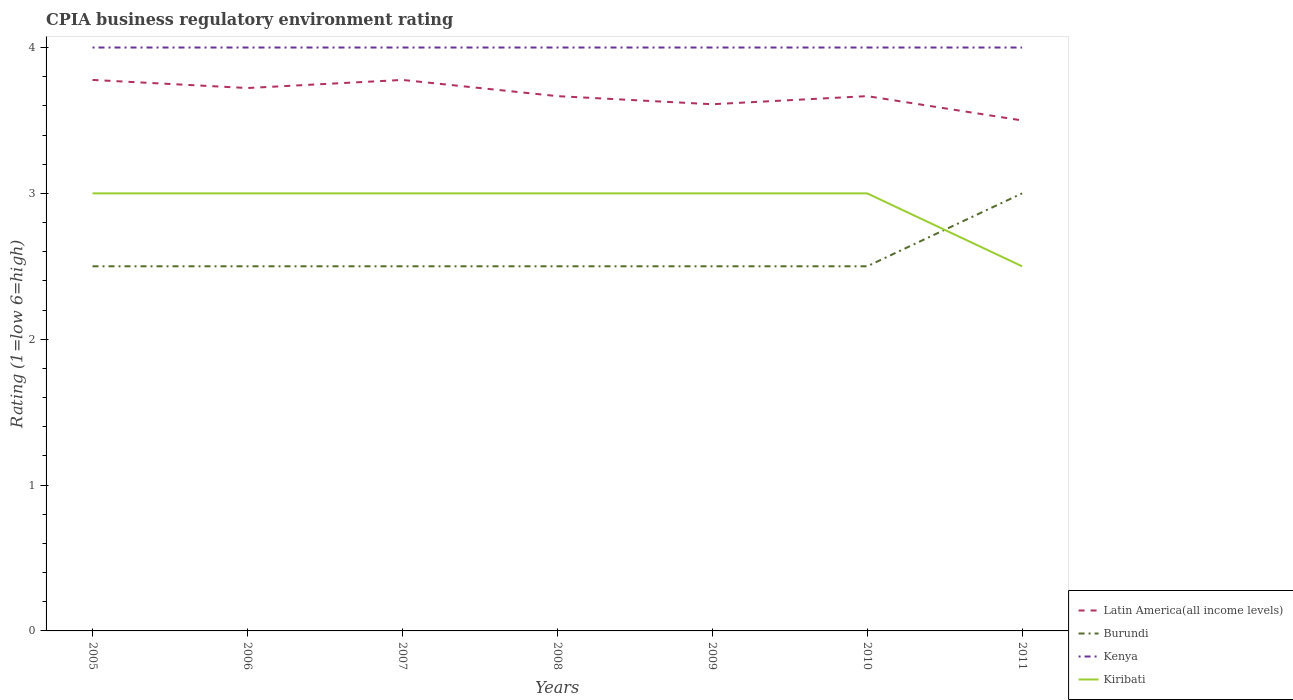How many different coloured lines are there?
Make the answer very short. 4. Across all years, what is the maximum CPIA rating in Burundi?
Your response must be concise. 2.5. In which year was the CPIA rating in Kiribati maximum?
Offer a very short reply. 2011. What is the total CPIA rating in Latin America(all income levels) in the graph?
Provide a succinct answer. 0.11. What is the difference between the highest and the second highest CPIA rating in Kenya?
Your answer should be very brief. 0. What is the difference between the highest and the lowest CPIA rating in Kenya?
Offer a very short reply. 0. How many lines are there?
Your answer should be compact. 4. How many years are there in the graph?
Your response must be concise. 7. What is the difference between two consecutive major ticks on the Y-axis?
Provide a short and direct response. 1. Does the graph contain grids?
Offer a terse response. No. Where does the legend appear in the graph?
Provide a succinct answer. Bottom right. How are the legend labels stacked?
Keep it short and to the point. Vertical. What is the title of the graph?
Give a very brief answer. CPIA business regulatory environment rating. What is the label or title of the Y-axis?
Your answer should be compact. Rating (1=low 6=high). What is the Rating (1=low 6=high) of Latin America(all income levels) in 2005?
Give a very brief answer. 3.78. What is the Rating (1=low 6=high) of Burundi in 2005?
Your response must be concise. 2.5. What is the Rating (1=low 6=high) of Latin America(all income levels) in 2006?
Make the answer very short. 3.72. What is the Rating (1=low 6=high) in Kiribati in 2006?
Provide a short and direct response. 3. What is the Rating (1=low 6=high) in Latin America(all income levels) in 2007?
Make the answer very short. 3.78. What is the Rating (1=low 6=high) of Burundi in 2007?
Ensure brevity in your answer.  2.5. What is the Rating (1=low 6=high) in Kiribati in 2007?
Make the answer very short. 3. What is the Rating (1=low 6=high) of Latin America(all income levels) in 2008?
Offer a very short reply. 3.67. What is the Rating (1=low 6=high) in Kenya in 2008?
Keep it short and to the point. 4. What is the Rating (1=low 6=high) of Kiribati in 2008?
Your response must be concise. 3. What is the Rating (1=low 6=high) of Latin America(all income levels) in 2009?
Offer a terse response. 3.61. What is the Rating (1=low 6=high) of Burundi in 2009?
Provide a succinct answer. 2.5. What is the Rating (1=low 6=high) in Kiribati in 2009?
Provide a succinct answer. 3. What is the Rating (1=low 6=high) of Latin America(all income levels) in 2010?
Give a very brief answer. 3.67. What is the Rating (1=low 6=high) of Kiribati in 2010?
Make the answer very short. 3. What is the Rating (1=low 6=high) in Latin America(all income levels) in 2011?
Give a very brief answer. 3.5. What is the Rating (1=low 6=high) in Burundi in 2011?
Keep it short and to the point. 3. What is the Rating (1=low 6=high) of Kiribati in 2011?
Offer a terse response. 2.5. Across all years, what is the maximum Rating (1=low 6=high) in Latin America(all income levels)?
Offer a terse response. 3.78. Across all years, what is the maximum Rating (1=low 6=high) of Burundi?
Your answer should be very brief. 3. Across all years, what is the maximum Rating (1=low 6=high) of Kenya?
Provide a short and direct response. 4. Across all years, what is the maximum Rating (1=low 6=high) in Kiribati?
Your response must be concise. 3. Across all years, what is the minimum Rating (1=low 6=high) in Kenya?
Ensure brevity in your answer.  4. What is the total Rating (1=low 6=high) in Latin America(all income levels) in the graph?
Provide a succinct answer. 25.72. What is the total Rating (1=low 6=high) in Kiribati in the graph?
Offer a terse response. 20.5. What is the difference between the Rating (1=low 6=high) in Latin America(all income levels) in 2005 and that in 2006?
Offer a terse response. 0.06. What is the difference between the Rating (1=low 6=high) of Kenya in 2005 and that in 2006?
Give a very brief answer. 0. What is the difference between the Rating (1=low 6=high) of Kiribati in 2005 and that in 2006?
Provide a succinct answer. 0. What is the difference between the Rating (1=low 6=high) in Latin America(all income levels) in 2005 and that in 2007?
Give a very brief answer. 0. What is the difference between the Rating (1=low 6=high) in Burundi in 2005 and that in 2007?
Provide a succinct answer. 0. What is the difference between the Rating (1=low 6=high) of Kiribati in 2005 and that in 2007?
Your response must be concise. 0. What is the difference between the Rating (1=low 6=high) in Burundi in 2005 and that in 2008?
Your response must be concise. 0. What is the difference between the Rating (1=low 6=high) of Kiribati in 2005 and that in 2009?
Your answer should be very brief. 0. What is the difference between the Rating (1=low 6=high) in Latin America(all income levels) in 2005 and that in 2010?
Give a very brief answer. 0.11. What is the difference between the Rating (1=low 6=high) in Burundi in 2005 and that in 2010?
Provide a succinct answer. 0. What is the difference between the Rating (1=low 6=high) in Kiribati in 2005 and that in 2010?
Keep it short and to the point. 0. What is the difference between the Rating (1=low 6=high) of Latin America(all income levels) in 2005 and that in 2011?
Offer a very short reply. 0.28. What is the difference between the Rating (1=low 6=high) of Latin America(all income levels) in 2006 and that in 2007?
Ensure brevity in your answer.  -0.06. What is the difference between the Rating (1=low 6=high) of Kenya in 2006 and that in 2007?
Your answer should be very brief. 0. What is the difference between the Rating (1=low 6=high) in Kiribati in 2006 and that in 2007?
Your response must be concise. 0. What is the difference between the Rating (1=low 6=high) in Latin America(all income levels) in 2006 and that in 2008?
Keep it short and to the point. 0.06. What is the difference between the Rating (1=low 6=high) in Burundi in 2006 and that in 2008?
Provide a succinct answer. 0. What is the difference between the Rating (1=low 6=high) of Kenya in 2006 and that in 2008?
Offer a terse response. 0. What is the difference between the Rating (1=low 6=high) in Burundi in 2006 and that in 2009?
Give a very brief answer. 0. What is the difference between the Rating (1=low 6=high) of Kenya in 2006 and that in 2009?
Ensure brevity in your answer.  0. What is the difference between the Rating (1=low 6=high) in Latin America(all income levels) in 2006 and that in 2010?
Your response must be concise. 0.06. What is the difference between the Rating (1=low 6=high) in Burundi in 2006 and that in 2010?
Offer a very short reply. 0. What is the difference between the Rating (1=low 6=high) of Kenya in 2006 and that in 2010?
Your answer should be compact. 0. What is the difference between the Rating (1=low 6=high) in Latin America(all income levels) in 2006 and that in 2011?
Make the answer very short. 0.22. What is the difference between the Rating (1=low 6=high) of Burundi in 2006 and that in 2011?
Make the answer very short. -0.5. What is the difference between the Rating (1=low 6=high) in Latin America(all income levels) in 2007 and that in 2008?
Give a very brief answer. 0.11. What is the difference between the Rating (1=low 6=high) of Kenya in 2007 and that in 2008?
Ensure brevity in your answer.  0. What is the difference between the Rating (1=low 6=high) in Burundi in 2007 and that in 2009?
Your answer should be very brief. 0. What is the difference between the Rating (1=low 6=high) in Burundi in 2007 and that in 2010?
Provide a short and direct response. 0. What is the difference between the Rating (1=low 6=high) of Kiribati in 2007 and that in 2010?
Your response must be concise. 0. What is the difference between the Rating (1=low 6=high) of Latin America(all income levels) in 2007 and that in 2011?
Provide a short and direct response. 0.28. What is the difference between the Rating (1=low 6=high) in Burundi in 2007 and that in 2011?
Keep it short and to the point. -0.5. What is the difference between the Rating (1=low 6=high) of Kenya in 2007 and that in 2011?
Provide a succinct answer. 0. What is the difference between the Rating (1=low 6=high) in Kiribati in 2007 and that in 2011?
Provide a succinct answer. 0.5. What is the difference between the Rating (1=low 6=high) in Latin America(all income levels) in 2008 and that in 2009?
Your answer should be very brief. 0.06. What is the difference between the Rating (1=low 6=high) in Kenya in 2008 and that in 2009?
Your answer should be very brief. 0. What is the difference between the Rating (1=low 6=high) in Burundi in 2008 and that in 2010?
Give a very brief answer. 0. What is the difference between the Rating (1=low 6=high) of Kenya in 2008 and that in 2011?
Your answer should be compact. 0. What is the difference between the Rating (1=low 6=high) of Latin America(all income levels) in 2009 and that in 2010?
Ensure brevity in your answer.  -0.06. What is the difference between the Rating (1=low 6=high) of Burundi in 2009 and that in 2010?
Make the answer very short. 0. What is the difference between the Rating (1=low 6=high) of Kenya in 2009 and that in 2010?
Ensure brevity in your answer.  0. What is the difference between the Rating (1=low 6=high) in Latin America(all income levels) in 2009 and that in 2011?
Offer a terse response. 0.11. What is the difference between the Rating (1=low 6=high) of Burundi in 2009 and that in 2011?
Offer a terse response. -0.5. What is the difference between the Rating (1=low 6=high) of Kiribati in 2009 and that in 2011?
Offer a very short reply. 0.5. What is the difference between the Rating (1=low 6=high) of Latin America(all income levels) in 2005 and the Rating (1=low 6=high) of Burundi in 2006?
Offer a very short reply. 1.28. What is the difference between the Rating (1=low 6=high) of Latin America(all income levels) in 2005 and the Rating (1=low 6=high) of Kenya in 2006?
Provide a short and direct response. -0.22. What is the difference between the Rating (1=low 6=high) in Latin America(all income levels) in 2005 and the Rating (1=low 6=high) in Kiribati in 2006?
Provide a succinct answer. 0.78. What is the difference between the Rating (1=low 6=high) of Latin America(all income levels) in 2005 and the Rating (1=low 6=high) of Burundi in 2007?
Your answer should be compact. 1.28. What is the difference between the Rating (1=low 6=high) of Latin America(all income levels) in 2005 and the Rating (1=low 6=high) of Kenya in 2007?
Provide a short and direct response. -0.22. What is the difference between the Rating (1=low 6=high) of Latin America(all income levels) in 2005 and the Rating (1=low 6=high) of Kiribati in 2007?
Provide a short and direct response. 0.78. What is the difference between the Rating (1=low 6=high) in Burundi in 2005 and the Rating (1=low 6=high) in Kenya in 2007?
Provide a short and direct response. -1.5. What is the difference between the Rating (1=low 6=high) in Kenya in 2005 and the Rating (1=low 6=high) in Kiribati in 2007?
Keep it short and to the point. 1. What is the difference between the Rating (1=low 6=high) in Latin America(all income levels) in 2005 and the Rating (1=low 6=high) in Burundi in 2008?
Make the answer very short. 1.28. What is the difference between the Rating (1=low 6=high) of Latin America(all income levels) in 2005 and the Rating (1=low 6=high) of Kenya in 2008?
Offer a very short reply. -0.22. What is the difference between the Rating (1=low 6=high) of Burundi in 2005 and the Rating (1=low 6=high) of Kenya in 2008?
Your response must be concise. -1.5. What is the difference between the Rating (1=low 6=high) in Kenya in 2005 and the Rating (1=low 6=high) in Kiribati in 2008?
Offer a very short reply. 1. What is the difference between the Rating (1=low 6=high) in Latin America(all income levels) in 2005 and the Rating (1=low 6=high) in Burundi in 2009?
Offer a very short reply. 1.28. What is the difference between the Rating (1=low 6=high) of Latin America(all income levels) in 2005 and the Rating (1=low 6=high) of Kenya in 2009?
Provide a short and direct response. -0.22. What is the difference between the Rating (1=low 6=high) in Kenya in 2005 and the Rating (1=low 6=high) in Kiribati in 2009?
Give a very brief answer. 1. What is the difference between the Rating (1=low 6=high) of Latin America(all income levels) in 2005 and the Rating (1=low 6=high) of Burundi in 2010?
Your answer should be very brief. 1.28. What is the difference between the Rating (1=low 6=high) in Latin America(all income levels) in 2005 and the Rating (1=low 6=high) in Kenya in 2010?
Give a very brief answer. -0.22. What is the difference between the Rating (1=low 6=high) of Latin America(all income levels) in 2005 and the Rating (1=low 6=high) of Kiribati in 2010?
Offer a terse response. 0.78. What is the difference between the Rating (1=low 6=high) in Burundi in 2005 and the Rating (1=low 6=high) in Kiribati in 2010?
Ensure brevity in your answer.  -0.5. What is the difference between the Rating (1=low 6=high) of Kenya in 2005 and the Rating (1=low 6=high) of Kiribati in 2010?
Keep it short and to the point. 1. What is the difference between the Rating (1=low 6=high) in Latin America(all income levels) in 2005 and the Rating (1=low 6=high) in Kenya in 2011?
Your answer should be compact. -0.22. What is the difference between the Rating (1=low 6=high) in Latin America(all income levels) in 2005 and the Rating (1=low 6=high) in Kiribati in 2011?
Give a very brief answer. 1.28. What is the difference between the Rating (1=low 6=high) of Burundi in 2005 and the Rating (1=low 6=high) of Kiribati in 2011?
Provide a succinct answer. 0. What is the difference between the Rating (1=low 6=high) of Latin America(all income levels) in 2006 and the Rating (1=low 6=high) of Burundi in 2007?
Provide a short and direct response. 1.22. What is the difference between the Rating (1=low 6=high) in Latin America(all income levels) in 2006 and the Rating (1=low 6=high) in Kenya in 2007?
Give a very brief answer. -0.28. What is the difference between the Rating (1=low 6=high) of Latin America(all income levels) in 2006 and the Rating (1=low 6=high) of Kiribati in 2007?
Your response must be concise. 0.72. What is the difference between the Rating (1=low 6=high) in Burundi in 2006 and the Rating (1=low 6=high) in Kenya in 2007?
Ensure brevity in your answer.  -1.5. What is the difference between the Rating (1=low 6=high) of Kenya in 2006 and the Rating (1=low 6=high) of Kiribati in 2007?
Offer a terse response. 1. What is the difference between the Rating (1=low 6=high) of Latin America(all income levels) in 2006 and the Rating (1=low 6=high) of Burundi in 2008?
Your answer should be compact. 1.22. What is the difference between the Rating (1=low 6=high) in Latin America(all income levels) in 2006 and the Rating (1=low 6=high) in Kenya in 2008?
Provide a short and direct response. -0.28. What is the difference between the Rating (1=low 6=high) in Latin America(all income levels) in 2006 and the Rating (1=low 6=high) in Kiribati in 2008?
Your response must be concise. 0.72. What is the difference between the Rating (1=low 6=high) in Kenya in 2006 and the Rating (1=low 6=high) in Kiribati in 2008?
Make the answer very short. 1. What is the difference between the Rating (1=low 6=high) in Latin America(all income levels) in 2006 and the Rating (1=low 6=high) in Burundi in 2009?
Keep it short and to the point. 1.22. What is the difference between the Rating (1=low 6=high) in Latin America(all income levels) in 2006 and the Rating (1=low 6=high) in Kenya in 2009?
Your answer should be very brief. -0.28. What is the difference between the Rating (1=low 6=high) in Latin America(all income levels) in 2006 and the Rating (1=low 6=high) in Kiribati in 2009?
Ensure brevity in your answer.  0.72. What is the difference between the Rating (1=low 6=high) in Kenya in 2006 and the Rating (1=low 6=high) in Kiribati in 2009?
Give a very brief answer. 1. What is the difference between the Rating (1=low 6=high) in Latin America(all income levels) in 2006 and the Rating (1=low 6=high) in Burundi in 2010?
Give a very brief answer. 1.22. What is the difference between the Rating (1=low 6=high) in Latin America(all income levels) in 2006 and the Rating (1=low 6=high) in Kenya in 2010?
Keep it short and to the point. -0.28. What is the difference between the Rating (1=low 6=high) of Latin America(all income levels) in 2006 and the Rating (1=low 6=high) of Kiribati in 2010?
Provide a short and direct response. 0.72. What is the difference between the Rating (1=low 6=high) in Burundi in 2006 and the Rating (1=low 6=high) in Kenya in 2010?
Offer a terse response. -1.5. What is the difference between the Rating (1=low 6=high) in Latin America(all income levels) in 2006 and the Rating (1=low 6=high) in Burundi in 2011?
Your answer should be compact. 0.72. What is the difference between the Rating (1=low 6=high) of Latin America(all income levels) in 2006 and the Rating (1=low 6=high) of Kenya in 2011?
Give a very brief answer. -0.28. What is the difference between the Rating (1=low 6=high) in Latin America(all income levels) in 2006 and the Rating (1=low 6=high) in Kiribati in 2011?
Provide a succinct answer. 1.22. What is the difference between the Rating (1=low 6=high) of Latin America(all income levels) in 2007 and the Rating (1=low 6=high) of Burundi in 2008?
Make the answer very short. 1.28. What is the difference between the Rating (1=low 6=high) in Latin America(all income levels) in 2007 and the Rating (1=low 6=high) in Kenya in 2008?
Your answer should be very brief. -0.22. What is the difference between the Rating (1=low 6=high) of Latin America(all income levels) in 2007 and the Rating (1=low 6=high) of Kiribati in 2008?
Offer a terse response. 0.78. What is the difference between the Rating (1=low 6=high) of Kenya in 2007 and the Rating (1=low 6=high) of Kiribati in 2008?
Your answer should be very brief. 1. What is the difference between the Rating (1=low 6=high) in Latin America(all income levels) in 2007 and the Rating (1=low 6=high) in Burundi in 2009?
Make the answer very short. 1.28. What is the difference between the Rating (1=low 6=high) of Latin America(all income levels) in 2007 and the Rating (1=low 6=high) of Kenya in 2009?
Make the answer very short. -0.22. What is the difference between the Rating (1=low 6=high) in Latin America(all income levels) in 2007 and the Rating (1=low 6=high) in Kiribati in 2009?
Offer a terse response. 0.78. What is the difference between the Rating (1=low 6=high) of Burundi in 2007 and the Rating (1=low 6=high) of Kenya in 2009?
Provide a succinct answer. -1.5. What is the difference between the Rating (1=low 6=high) of Burundi in 2007 and the Rating (1=low 6=high) of Kiribati in 2009?
Keep it short and to the point. -0.5. What is the difference between the Rating (1=low 6=high) in Latin America(all income levels) in 2007 and the Rating (1=low 6=high) in Burundi in 2010?
Provide a succinct answer. 1.28. What is the difference between the Rating (1=low 6=high) of Latin America(all income levels) in 2007 and the Rating (1=low 6=high) of Kenya in 2010?
Keep it short and to the point. -0.22. What is the difference between the Rating (1=low 6=high) of Burundi in 2007 and the Rating (1=low 6=high) of Kiribati in 2010?
Make the answer very short. -0.5. What is the difference between the Rating (1=low 6=high) in Latin America(all income levels) in 2007 and the Rating (1=low 6=high) in Burundi in 2011?
Your response must be concise. 0.78. What is the difference between the Rating (1=low 6=high) in Latin America(all income levels) in 2007 and the Rating (1=low 6=high) in Kenya in 2011?
Offer a very short reply. -0.22. What is the difference between the Rating (1=low 6=high) in Latin America(all income levels) in 2007 and the Rating (1=low 6=high) in Kiribati in 2011?
Provide a succinct answer. 1.28. What is the difference between the Rating (1=low 6=high) of Burundi in 2007 and the Rating (1=low 6=high) of Kenya in 2011?
Your answer should be very brief. -1.5. What is the difference between the Rating (1=low 6=high) in Burundi in 2007 and the Rating (1=low 6=high) in Kiribati in 2011?
Make the answer very short. 0. What is the difference between the Rating (1=low 6=high) in Kenya in 2007 and the Rating (1=low 6=high) in Kiribati in 2011?
Keep it short and to the point. 1.5. What is the difference between the Rating (1=low 6=high) of Latin America(all income levels) in 2008 and the Rating (1=low 6=high) of Burundi in 2009?
Your answer should be compact. 1.17. What is the difference between the Rating (1=low 6=high) of Latin America(all income levels) in 2008 and the Rating (1=low 6=high) of Kenya in 2009?
Provide a succinct answer. -0.33. What is the difference between the Rating (1=low 6=high) in Latin America(all income levels) in 2008 and the Rating (1=low 6=high) in Kiribati in 2009?
Ensure brevity in your answer.  0.67. What is the difference between the Rating (1=low 6=high) in Burundi in 2008 and the Rating (1=low 6=high) in Kiribati in 2009?
Your response must be concise. -0.5. What is the difference between the Rating (1=low 6=high) of Kenya in 2008 and the Rating (1=low 6=high) of Kiribati in 2009?
Offer a very short reply. 1. What is the difference between the Rating (1=low 6=high) of Latin America(all income levels) in 2008 and the Rating (1=low 6=high) of Kiribati in 2010?
Provide a succinct answer. 0.67. What is the difference between the Rating (1=low 6=high) in Burundi in 2008 and the Rating (1=low 6=high) in Kenya in 2010?
Provide a succinct answer. -1.5. What is the difference between the Rating (1=low 6=high) of Burundi in 2008 and the Rating (1=low 6=high) of Kiribati in 2010?
Offer a very short reply. -0.5. What is the difference between the Rating (1=low 6=high) of Kenya in 2008 and the Rating (1=low 6=high) of Kiribati in 2010?
Make the answer very short. 1. What is the difference between the Rating (1=low 6=high) in Latin America(all income levels) in 2008 and the Rating (1=low 6=high) in Burundi in 2011?
Offer a terse response. 0.67. What is the difference between the Rating (1=low 6=high) of Latin America(all income levels) in 2008 and the Rating (1=low 6=high) of Kiribati in 2011?
Your answer should be compact. 1.17. What is the difference between the Rating (1=low 6=high) of Burundi in 2008 and the Rating (1=low 6=high) of Kenya in 2011?
Provide a succinct answer. -1.5. What is the difference between the Rating (1=low 6=high) of Latin America(all income levels) in 2009 and the Rating (1=low 6=high) of Burundi in 2010?
Provide a short and direct response. 1.11. What is the difference between the Rating (1=low 6=high) in Latin America(all income levels) in 2009 and the Rating (1=low 6=high) in Kenya in 2010?
Your response must be concise. -0.39. What is the difference between the Rating (1=low 6=high) of Latin America(all income levels) in 2009 and the Rating (1=low 6=high) of Kiribati in 2010?
Offer a very short reply. 0.61. What is the difference between the Rating (1=low 6=high) in Burundi in 2009 and the Rating (1=low 6=high) in Kenya in 2010?
Your response must be concise. -1.5. What is the difference between the Rating (1=low 6=high) of Burundi in 2009 and the Rating (1=low 6=high) of Kiribati in 2010?
Keep it short and to the point. -0.5. What is the difference between the Rating (1=low 6=high) in Latin America(all income levels) in 2009 and the Rating (1=low 6=high) in Burundi in 2011?
Provide a short and direct response. 0.61. What is the difference between the Rating (1=low 6=high) in Latin America(all income levels) in 2009 and the Rating (1=low 6=high) in Kenya in 2011?
Keep it short and to the point. -0.39. What is the difference between the Rating (1=low 6=high) in Kenya in 2009 and the Rating (1=low 6=high) in Kiribati in 2011?
Give a very brief answer. 1.5. What is the difference between the Rating (1=low 6=high) in Latin America(all income levels) in 2010 and the Rating (1=low 6=high) in Kenya in 2011?
Offer a very short reply. -0.33. What is the difference between the Rating (1=low 6=high) in Latin America(all income levels) in 2010 and the Rating (1=low 6=high) in Kiribati in 2011?
Give a very brief answer. 1.17. What is the difference between the Rating (1=low 6=high) of Burundi in 2010 and the Rating (1=low 6=high) of Kiribati in 2011?
Offer a terse response. 0. What is the difference between the Rating (1=low 6=high) in Kenya in 2010 and the Rating (1=low 6=high) in Kiribati in 2011?
Make the answer very short. 1.5. What is the average Rating (1=low 6=high) of Latin America(all income levels) per year?
Make the answer very short. 3.67. What is the average Rating (1=low 6=high) of Burundi per year?
Provide a succinct answer. 2.57. What is the average Rating (1=low 6=high) of Kenya per year?
Provide a short and direct response. 4. What is the average Rating (1=low 6=high) in Kiribati per year?
Your response must be concise. 2.93. In the year 2005, what is the difference between the Rating (1=low 6=high) of Latin America(all income levels) and Rating (1=low 6=high) of Burundi?
Offer a very short reply. 1.28. In the year 2005, what is the difference between the Rating (1=low 6=high) of Latin America(all income levels) and Rating (1=low 6=high) of Kenya?
Your answer should be very brief. -0.22. In the year 2005, what is the difference between the Rating (1=low 6=high) in Burundi and Rating (1=low 6=high) in Kenya?
Your answer should be very brief. -1.5. In the year 2006, what is the difference between the Rating (1=low 6=high) in Latin America(all income levels) and Rating (1=low 6=high) in Burundi?
Your answer should be compact. 1.22. In the year 2006, what is the difference between the Rating (1=low 6=high) of Latin America(all income levels) and Rating (1=low 6=high) of Kenya?
Give a very brief answer. -0.28. In the year 2006, what is the difference between the Rating (1=low 6=high) in Latin America(all income levels) and Rating (1=low 6=high) in Kiribati?
Provide a succinct answer. 0.72. In the year 2006, what is the difference between the Rating (1=low 6=high) in Burundi and Rating (1=low 6=high) in Kiribati?
Ensure brevity in your answer.  -0.5. In the year 2007, what is the difference between the Rating (1=low 6=high) in Latin America(all income levels) and Rating (1=low 6=high) in Burundi?
Offer a very short reply. 1.28. In the year 2007, what is the difference between the Rating (1=low 6=high) in Latin America(all income levels) and Rating (1=low 6=high) in Kenya?
Provide a succinct answer. -0.22. In the year 2007, what is the difference between the Rating (1=low 6=high) of Latin America(all income levels) and Rating (1=low 6=high) of Kiribati?
Your answer should be compact. 0.78. In the year 2008, what is the difference between the Rating (1=low 6=high) of Latin America(all income levels) and Rating (1=low 6=high) of Burundi?
Your response must be concise. 1.17. In the year 2008, what is the difference between the Rating (1=low 6=high) in Latin America(all income levels) and Rating (1=low 6=high) in Kiribati?
Your answer should be compact. 0.67. In the year 2008, what is the difference between the Rating (1=low 6=high) in Kenya and Rating (1=low 6=high) in Kiribati?
Make the answer very short. 1. In the year 2009, what is the difference between the Rating (1=low 6=high) in Latin America(all income levels) and Rating (1=low 6=high) in Burundi?
Keep it short and to the point. 1.11. In the year 2009, what is the difference between the Rating (1=low 6=high) of Latin America(all income levels) and Rating (1=low 6=high) of Kenya?
Provide a succinct answer. -0.39. In the year 2009, what is the difference between the Rating (1=low 6=high) in Latin America(all income levels) and Rating (1=low 6=high) in Kiribati?
Your answer should be compact. 0.61. In the year 2009, what is the difference between the Rating (1=low 6=high) in Burundi and Rating (1=low 6=high) in Kiribati?
Your response must be concise. -0.5. In the year 2009, what is the difference between the Rating (1=low 6=high) in Kenya and Rating (1=low 6=high) in Kiribati?
Your answer should be very brief. 1. In the year 2010, what is the difference between the Rating (1=low 6=high) of Latin America(all income levels) and Rating (1=low 6=high) of Burundi?
Your answer should be very brief. 1.17. In the year 2010, what is the difference between the Rating (1=low 6=high) in Latin America(all income levels) and Rating (1=low 6=high) in Kiribati?
Provide a succinct answer. 0.67. In the year 2010, what is the difference between the Rating (1=low 6=high) in Burundi and Rating (1=low 6=high) in Kenya?
Your response must be concise. -1.5. In the year 2010, what is the difference between the Rating (1=low 6=high) in Burundi and Rating (1=low 6=high) in Kiribati?
Make the answer very short. -0.5. In the year 2010, what is the difference between the Rating (1=low 6=high) of Kenya and Rating (1=low 6=high) of Kiribati?
Keep it short and to the point. 1. In the year 2011, what is the difference between the Rating (1=low 6=high) of Latin America(all income levels) and Rating (1=low 6=high) of Kenya?
Provide a succinct answer. -0.5. In the year 2011, what is the difference between the Rating (1=low 6=high) of Latin America(all income levels) and Rating (1=low 6=high) of Kiribati?
Your answer should be very brief. 1. In the year 2011, what is the difference between the Rating (1=low 6=high) of Burundi and Rating (1=low 6=high) of Kenya?
Offer a terse response. -1. In the year 2011, what is the difference between the Rating (1=low 6=high) in Kenya and Rating (1=low 6=high) in Kiribati?
Offer a very short reply. 1.5. What is the ratio of the Rating (1=low 6=high) of Latin America(all income levels) in 2005 to that in 2006?
Provide a short and direct response. 1.01. What is the ratio of the Rating (1=low 6=high) of Burundi in 2005 to that in 2006?
Offer a terse response. 1. What is the ratio of the Rating (1=low 6=high) of Kenya in 2005 to that in 2006?
Your response must be concise. 1. What is the ratio of the Rating (1=low 6=high) in Kiribati in 2005 to that in 2006?
Provide a short and direct response. 1. What is the ratio of the Rating (1=low 6=high) in Latin America(all income levels) in 2005 to that in 2007?
Provide a short and direct response. 1. What is the ratio of the Rating (1=low 6=high) of Kiribati in 2005 to that in 2007?
Offer a very short reply. 1. What is the ratio of the Rating (1=low 6=high) in Latin America(all income levels) in 2005 to that in 2008?
Your answer should be very brief. 1.03. What is the ratio of the Rating (1=low 6=high) of Burundi in 2005 to that in 2008?
Ensure brevity in your answer.  1. What is the ratio of the Rating (1=low 6=high) in Kenya in 2005 to that in 2008?
Keep it short and to the point. 1. What is the ratio of the Rating (1=low 6=high) in Latin America(all income levels) in 2005 to that in 2009?
Offer a very short reply. 1.05. What is the ratio of the Rating (1=low 6=high) in Burundi in 2005 to that in 2009?
Your response must be concise. 1. What is the ratio of the Rating (1=low 6=high) in Latin America(all income levels) in 2005 to that in 2010?
Give a very brief answer. 1.03. What is the ratio of the Rating (1=low 6=high) in Burundi in 2005 to that in 2010?
Make the answer very short. 1. What is the ratio of the Rating (1=low 6=high) in Kiribati in 2005 to that in 2010?
Your answer should be very brief. 1. What is the ratio of the Rating (1=low 6=high) in Latin America(all income levels) in 2005 to that in 2011?
Give a very brief answer. 1.08. What is the ratio of the Rating (1=low 6=high) in Burundi in 2005 to that in 2011?
Your response must be concise. 0.83. What is the ratio of the Rating (1=low 6=high) of Kiribati in 2005 to that in 2011?
Make the answer very short. 1.2. What is the ratio of the Rating (1=low 6=high) in Latin America(all income levels) in 2006 to that in 2007?
Offer a terse response. 0.99. What is the ratio of the Rating (1=low 6=high) of Kiribati in 2006 to that in 2007?
Give a very brief answer. 1. What is the ratio of the Rating (1=low 6=high) of Latin America(all income levels) in 2006 to that in 2008?
Make the answer very short. 1.02. What is the ratio of the Rating (1=low 6=high) of Kenya in 2006 to that in 2008?
Provide a succinct answer. 1. What is the ratio of the Rating (1=low 6=high) of Latin America(all income levels) in 2006 to that in 2009?
Your response must be concise. 1.03. What is the ratio of the Rating (1=low 6=high) of Kiribati in 2006 to that in 2009?
Make the answer very short. 1. What is the ratio of the Rating (1=low 6=high) in Latin America(all income levels) in 2006 to that in 2010?
Give a very brief answer. 1.02. What is the ratio of the Rating (1=low 6=high) of Burundi in 2006 to that in 2010?
Make the answer very short. 1. What is the ratio of the Rating (1=low 6=high) of Kenya in 2006 to that in 2010?
Offer a terse response. 1. What is the ratio of the Rating (1=low 6=high) in Kiribati in 2006 to that in 2010?
Offer a very short reply. 1. What is the ratio of the Rating (1=low 6=high) of Latin America(all income levels) in 2006 to that in 2011?
Make the answer very short. 1.06. What is the ratio of the Rating (1=low 6=high) of Burundi in 2006 to that in 2011?
Your response must be concise. 0.83. What is the ratio of the Rating (1=low 6=high) in Kenya in 2006 to that in 2011?
Give a very brief answer. 1. What is the ratio of the Rating (1=low 6=high) in Latin America(all income levels) in 2007 to that in 2008?
Provide a short and direct response. 1.03. What is the ratio of the Rating (1=low 6=high) of Kenya in 2007 to that in 2008?
Ensure brevity in your answer.  1. What is the ratio of the Rating (1=low 6=high) in Kiribati in 2007 to that in 2008?
Offer a very short reply. 1. What is the ratio of the Rating (1=low 6=high) of Latin America(all income levels) in 2007 to that in 2009?
Provide a succinct answer. 1.05. What is the ratio of the Rating (1=low 6=high) of Kenya in 2007 to that in 2009?
Make the answer very short. 1. What is the ratio of the Rating (1=low 6=high) of Latin America(all income levels) in 2007 to that in 2010?
Provide a succinct answer. 1.03. What is the ratio of the Rating (1=low 6=high) of Kenya in 2007 to that in 2010?
Offer a terse response. 1. What is the ratio of the Rating (1=low 6=high) in Kiribati in 2007 to that in 2010?
Give a very brief answer. 1. What is the ratio of the Rating (1=low 6=high) of Latin America(all income levels) in 2007 to that in 2011?
Provide a succinct answer. 1.08. What is the ratio of the Rating (1=low 6=high) in Kenya in 2007 to that in 2011?
Ensure brevity in your answer.  1. What is the ratio of the Rating (1=low 6=high) in Latin America(all income levels) in 2008 to that in 2009?
Your answer should be very brief. 1.02. What is the ratio of the Rating (1=low 6=high) of Burundi in 2008 to that in 2009?
Your answer should be very brief. 1. What is the ratio of the Rating (1=low 6=high) of Kenya in 2008 to that in 2009?
Your answer should be compact. 1. What is the ratio of the Rating (1=low 6=high) in Latin America(all income levels) in 2008 to that in 2010?
Your answer should be compact. 1. What is the ratio of the Rating (1=low 6=high) of Burundi in 2008 to that in 2010?
Offer a very short reply. 1. What is the ratio of the Rating (1=low 6=high) of Kenya in 2008 to that in 2010?
Your answer should be very brief. 1. What is the ratio of the Rating (1=low 6=high) of Latin America(all income levels) in 2008 to that in 2011?
Keep it short and to the point. 1.05. What is the ratio of the Rating (1=low 6=high) in Latin America(all income levels) in 2009 to that in 2010?
Provide a succinct answer. 0.98. What is the ratio of the Rating (1=low 6=high) of Kenya in 2009 to that in 2010?
Your answer should be very brief. 1. What is the ratio of the Rating (1=low 6=high) in Latin America(all income levels) in 2009 to that in 2011?
Keep it short and to the point. 1.03. What is the ratio of the Rating (1=low 6=high) of Burundi in 2009 to that in 2011?
Keep it short and to the point. 0.83. What is the ratio of the Rating (1=low 6=high) in Latin America(all income levels) in 2010 to that in 2011?
Offer a terse response. 1.05. What is the ratio of the Rating (1=low 6=high) in Kenya in 2010 to that in 2011?
Provide a short and direct response. 1. What is the ratio of the Rating (1=low 6=high) in Kiribati in 2010 to that in 2011?
Ensure brevity in your answer.  1.2. What is the difference between the highest and the second highest Rating (1=low 6=high) of Burundi?
Your response must be concise. 0.5. What is the difference between the highest and the lowest Rating (1=low 6=high) of Latin America(all income levels)?
Give a very brief answer. 0.28. What is the difference between the highest and the lowest Rating (1=low 6=high) in Kenya?
Offer a very short reply. 0. 